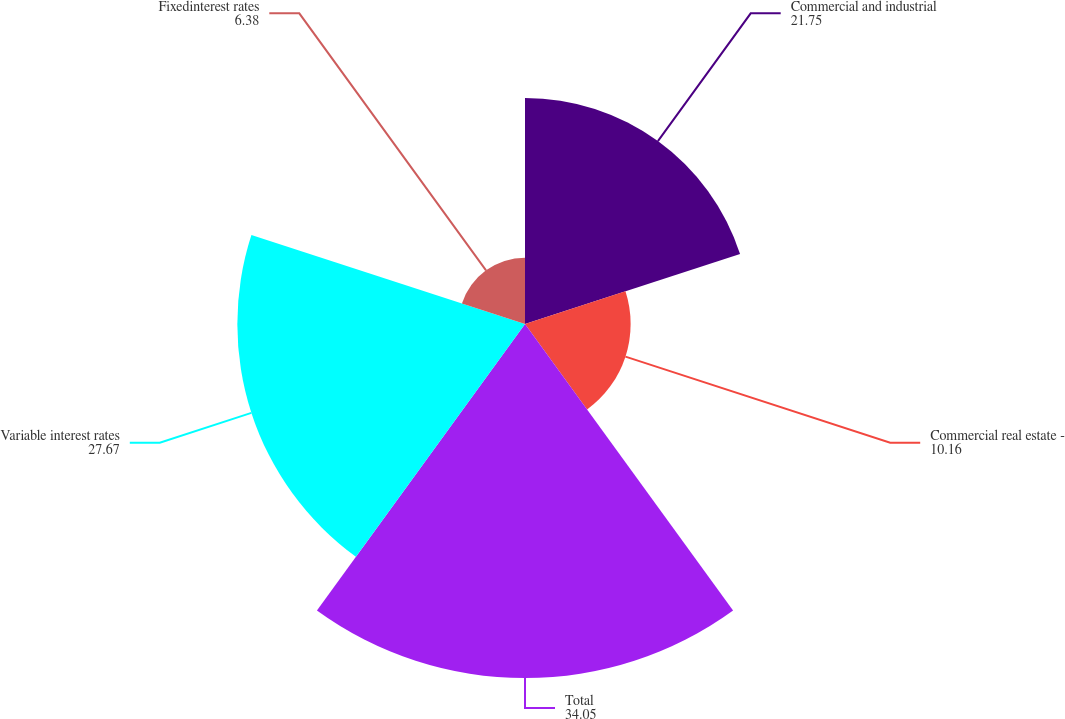Convert chart to OTSL. <chart><loc_0><loc_0><loc_500><loc_500><pie_chart><fcel>Commercial and industrial<fcel>Commercial real estate -<fcel>Total<fcel>Variable interest rates<fcel>Fixedinterest rates<nl><fcel>21.75%<fcel>10.16%<fcel>34.05%<fcel>27.67%<fcel>6.38%<nl></chart> 